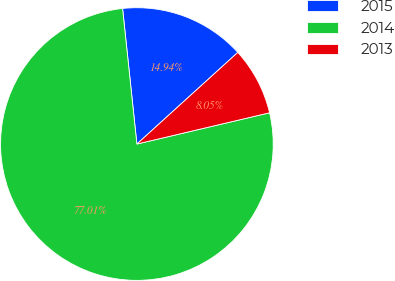Convert chart to OTSL. <chart><loc_0><loc_0><loc_500><loc_500><pie_chart><fcel>2015<fcel>2014<fcel>2013<nl><fcel>14.94%<fcel>77.01%<fcel>8.05%<nl></chart> 